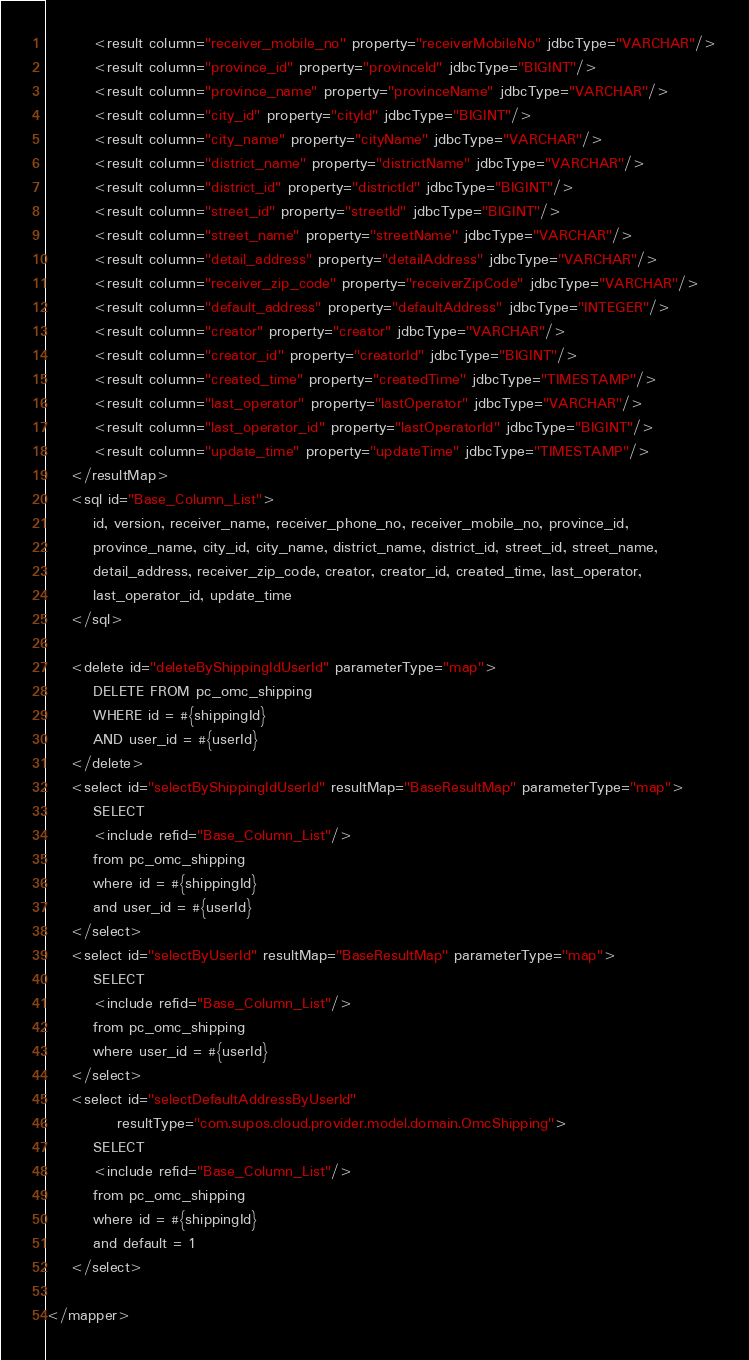Convert code to text. <code><loc_0><loc_0><loc_500><loc_500><_XML_>        <result column="receiver_mobile_no" property="receiverMobileNo" jdbcType="VARCHAR"/>
        <result column="province_id" property="provinceId" jdbcType="BIGINT"/>
        <result column="province_name" property="provinceName" jdbcType="VARCHAR"/>
        <result column="city_id" property="cityId" jdbcType="BIGINT"/>
        <result column="city_name" property="cityName" jdbcType="VARCHAR"/>
        <result column="district_name" property="districtName" jdbcType="VARCHAR"/>
        <result column="district_id" property="districtId" jdbcType="BIGINT"/>
        <result column="street_id" property="streetId" jdbcType="BIGINT"/>
        <result column="street_name" property="streetName" jdbcType="VARCHAR"/>
        <result column="detail_address" property="detailAddress" jdbcType="VARCHAR"/>
        <result column="receiver_zip_code" property="receiverZipCode" jdbcType="VARCHAR"/>
        <result column="default_address" property="defaultAddress" jdbcType="INTEGER"/>
        <result column="creator" property="creator" jdbcType="VARCHAR"/>
        <result column="creator_id" property="creatorId" jdbcType="BIGINT"/>
        <result column="created_time" property="createdTime" jdbcType="TIMESTAMP"/>
        <result column="last_operator" property="lastOperator" jdbcType="VARCHAR"/>
        <result column="last_operator_id" property="lastOperatorId" jdbcType="BIGINT"/>
        <result column="update_time" property="updateTime" jdbcType="TIMESTAMP"/>
    </resultMap>
    <sql id="Base_Column_List">
        id, version, receiver_name, receiver_phone_no, receiver_mobile_no, province_id,
        province_name, city_id, city_name, district_name, district_id, street_id, street_name,
        detail_address, receiver_zip_code, creator, creator_id, created_time, last_operator,
        last_operator_id, update_time
    </sql>

    <delete id="deleteByShippingIdUserId" parameterType="map">
        DELETE FROM pc_omc_shipping
        WHERE id = #{shippingId}
        AND user_id = #{userId}
    </delete>
    <select id="selectByShippingIdUserId" resultMap="BaseResultMap" parameterType="map">
        SELECT
        <include refid="Base_Column_List"/>
        from pc_omc_shipping
        where id = #{shippingId}
        and user_id = #{userId}
    </select>
    <select id="selectByUserId" resultMap="BaseResultMap" parameterType="map">
        SELECT
        <include refid="Base_Column_List"/>
        from pc_omc_shipping
        where user_id = #{userId}
    </select>
    <select id="selectDefaultAddressByUserId"
            resultType="com.supos.cloud.provider.model.domain.OmcShipping">
        SELECT
        <include refid="Base_Column_List"/>
        from pc_omc_shipping
        where id = #{shippingId}
        and default = 1
    </select>

</mapper></code> 